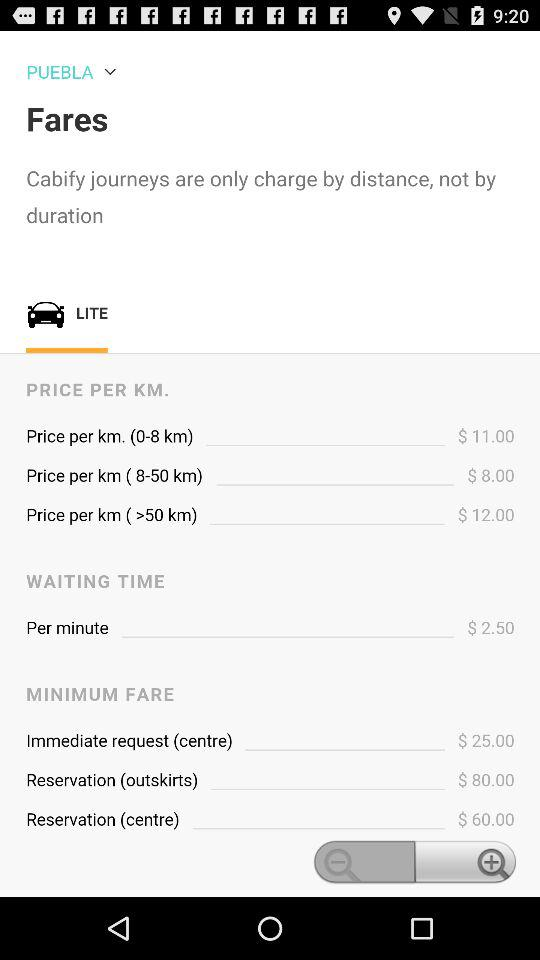What is the minimum fare for immediate request (centre)? The minimum fare for immediate request (centre) is $25. 